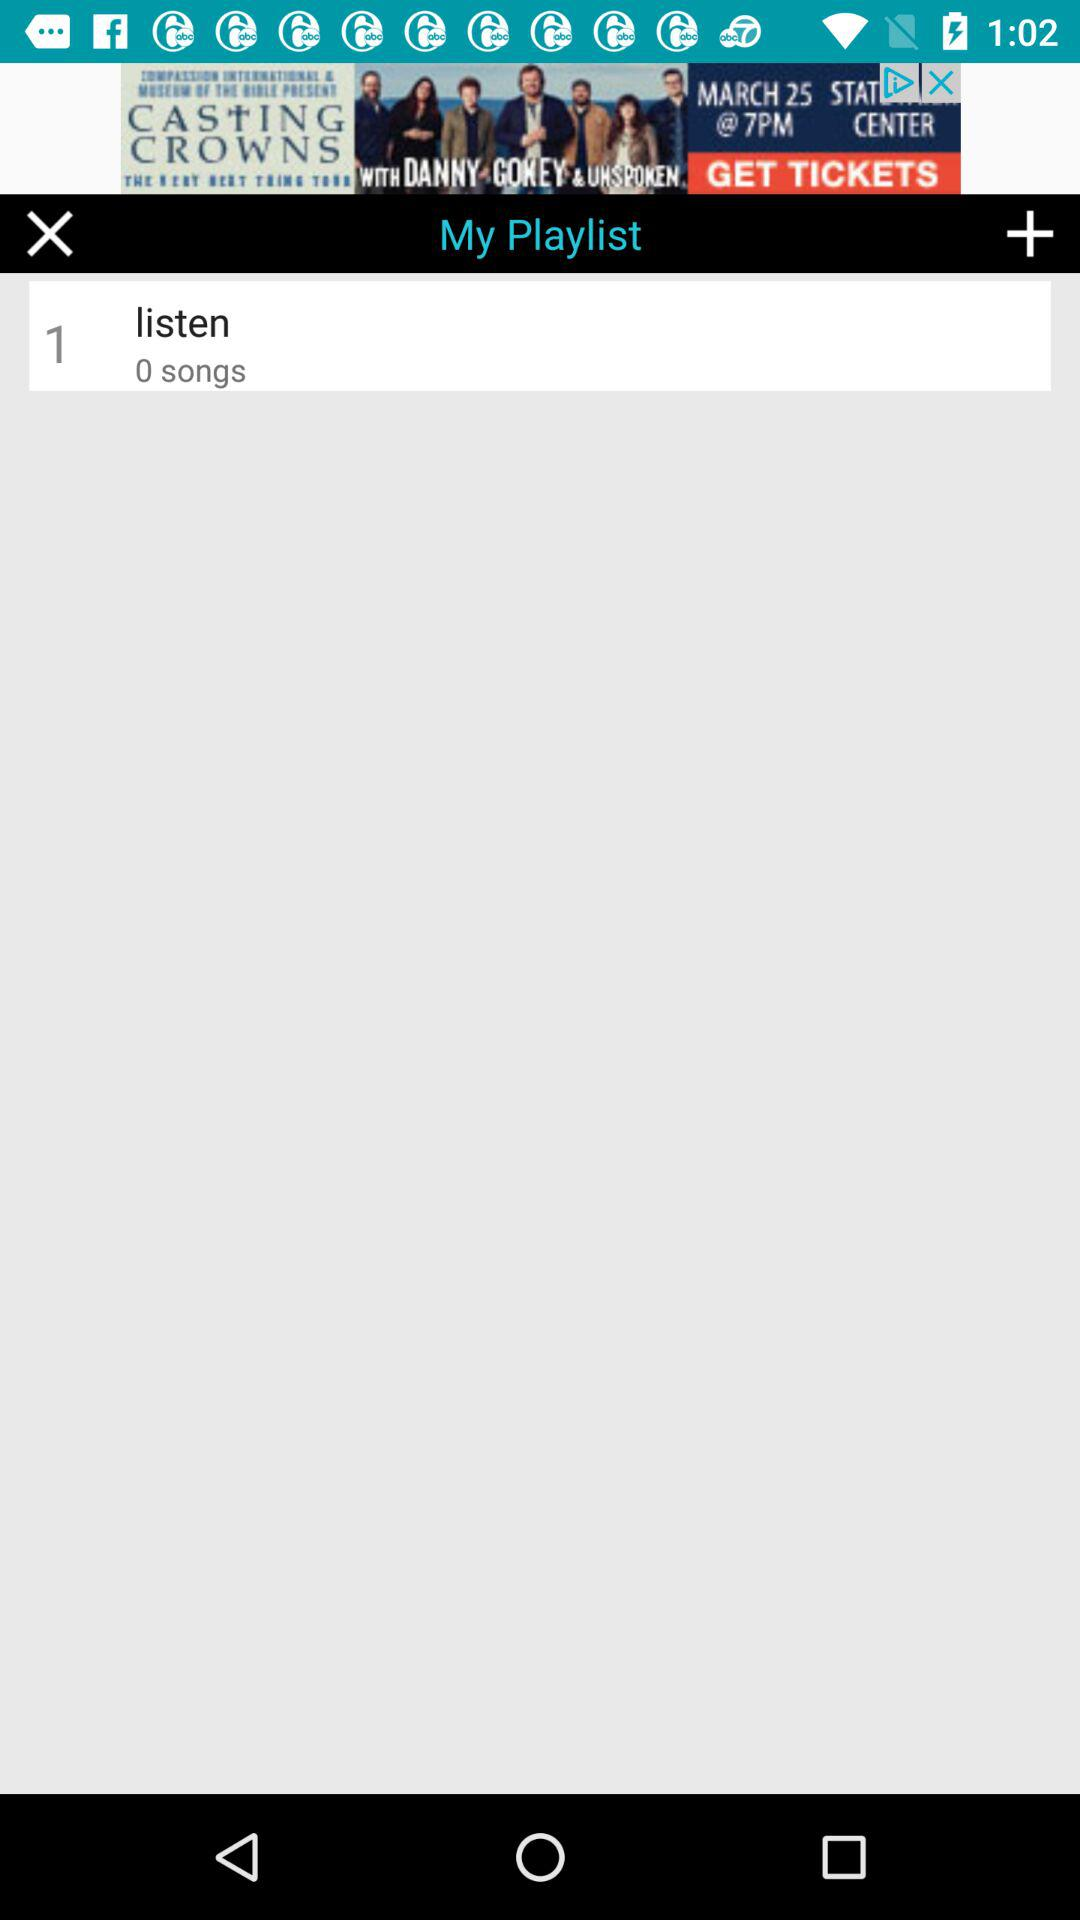How many songs are in the playlist? There are 0 songs. 